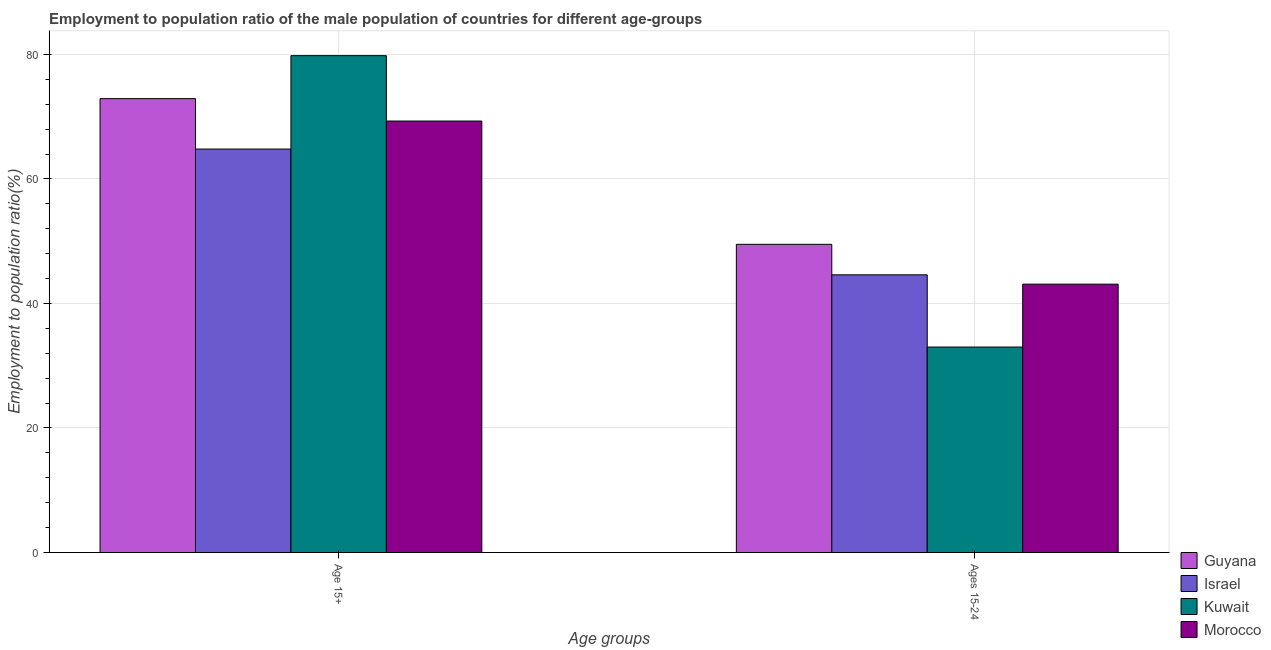How many different coloured bars are there?
Your answer should be very brief. 4. How many groups of bars are there?
Provide a short and direct response. 2. Are the number of bars per tick equal to the number of legend labels?
Give a very brief answer. Yes. How many bars are there on the 2nd tick from the left?
Provide a short and direct response. 4. How many bars are there on the 2nd tick from the right?
Keep it short and to the point. 4. What is the label of the 2nd group of bars from the left?
Provide a succinct answer. Ages 15-24. What is the employment to population ratio(age 15+) in Morocco?
Your response must be concise. 69.3. Across all countries, what is the maximum employment to population ratio(age 15+)?
Offer a very short reply. 79.8. Across all countries, what is the minimum employment to population ratio(age 15+)?
Provide a short and direct response. 64.8. In which country was the employment to population ratio(age 15+) maximum?
Provide a succinct answer. Kuwait. In which country was the employment to population ratio(age 15-24) minimum?
Ensure brevity in your answer.  Kuwait. What is the total employment to population ratio(age 15+) in the graph?
Your answer should be very brief. 286.8. What is the difference between the employment to population ratio(age 15-24) in Israel and that in Kuwait?
Keep it short and to the point. 11.6. What is the difference between the employment to population ratio(age 15+) in Morocco and the employment to population ratio(age 15-24) in Guyana?
Offer a very short reply. 19.8. What is the average employment to population ratio(age 15-24) per country?
Your answer should be compact. 42.55. What is the difference between the employment to population ratio(age 15+) and employment to population ratio(age 15-24) in Israel?
Provide a succinct answer. 20.2. What is the ratio of the employment to population ratio(age 15+) in Israel to that in Kuwait?
Your response must be concise. 0.81. In how many countries, is the employment to population ratio(age 15-24) greater than the average employment to population ratio(age 15-24) taken over all countries?
Your response must be concise. 3. What does the 4th bar from the left in Ages 15-24 represents?
Your answer should be very brief. Morocco. What does the 4th bar from the right in Age 15+ represents?
Make the answer very short. Guyana. Does the graph contain any zero values?
Provide a short and direct response. No. How are the legend labels stacked?
Provide a succinct answer. Vertical. What is the title of the graph?
Offer a terse response. Employment to population ratio of the male population of countries for different age-groups. Does "Central Europe" appear as one of the legend labels in the graph?
Give a very brief answer. No. What is the label or title of the X-axis?
Offer a very short reply. Age groups. What is the label or title of the Y-axis?
Make the answer very short. Employment to population ratio(%). What is the Employment to population ratio(%) of Guyana in Age 15+?
Offer a very short reply. 72.9. What is the Employment to population ratio(%) in Israel in Age 15+?
Ensure brevity in your answer.  64.8. What is the Employment to population ratio(%) of Kuwait in Age 15+?
Offer a very short reply. 79.8. What is the Employment to population ratio(%) in Morocco in Age 15+?
Your answer should be very brief. 69.3. What is the Employment to population ratio(%) in Guyana in Ages 15-24?
Provide a short and direct response. 49.5. What is the Employment to population ratio(%) in Israel in Ages 15-24?
Provide a short and direct response. 44.6. What is the Employment to population ratio(%) of Morocco in Ages 15-24?
Your response must be concise. 43.1. Across all Age groups, what is the maximum Employment to population ratio(%) of Guyana?
Ensure brevity in your answer.  72.9. Across all Age groups, what is the maximum Employment to population ratio(%) of Israel?
Offer a very short reply. 64.8. Across all Age groups, what is the maximum Employment to population ratio(%) of Kuwait?
Offer a very short reply. 79.8. Across all Age groups, what is the maximum Employment to population ratio(%) in Morocco?
Give a very brief answer. 69.3. Across all Age groups, what is the minimum Employment to population ratio(%) in Guyana?
Keep it short and to the point. 49.5. Across all Age groups, what is the minimum Employment to population ratio(%) of Israel?
Offer a terse response. 44.6. Across all Age groups, what is the minimum Employment to population ratio(%) in Kuwait?
Provide a succinct answer. 33. Across all Age groups, what is the minimum Employment to population ratio(%) in Morocco?
Your answer should be compact. 43.1. What is the total Employment to population ratio(%) in Guyana in the graph?
Ensure brevity in your answer.  122.4. What is the total Employment to population ratio(%) of Israel in the graph?
Your answer should be very brief. 109.4. What is the total Employment to population ratio(%) in Kuwait in the graph?
Your answer should be very brief. 112.8. What is the total Employment to population ratio(%) in Morocco in the graph?
Offer a terse response. 112.4. What is the difference between the Employment to population ratio(%) of Guyana in Age 15+ and that in Ages 15-24?
Offer a very short reply. 23.4. What is the difference between the Employment to population ratio(%) of Israel in Age 15+ and that in Ages 15-24?
Provide a succinct answer. 20.2. What is the difference between the Employment to population ratio(%) in Kuwait in Age 15+ and that in Ages 15-24?
Offer a very short reply. 46.8. What is the difference between the Employment to population ratio(%) in Morocco in Age 15+ and that in Ages 15-24?
Give a very brief answer. 26.2. What is the difference between the Employment to population ratio(%) in Guyana in Age 15+ and the Employment to population ratio(%) in Israel in Ages 15-24?
Keep it short and to the point. 28.3. What is the difference between the Employment to population ratio(%) in Guyana in Age 15+ and the Employment to population ratio(%) in Kuwait in Ages 15-24?
Your answer should be very brief. 39.9. What is the difference between the Employment to population ratio(%) of Guyana in Age 15+ and the Employment to population ratio(%) of Morocco in Ages 15-24?
Offer a terse response. 29.8. What is the difference between the Employment to population ratio(%) of Israel in Age 15+ and the Employment to population ratio(%) of Kuwait in Ages 15-24?
Keep it short and to the point. 31.8. What is the difference between the Employment to population ratio(%) in Israel in Age 15+ and the Employment to population ratio(%) in Morocco in Ages 15-24?
Offer a very short reply. 21.7. What is the difference between the Employment to population ratio(%) of Kuwait in Age 15+ and the Employment to population ratio(%) of Morocco in Ages 15-24?
Give a very brief answer. 36.7. What is the average Employment to population ratio(%) in Guyana per Age groups?
Make the answer very short. 61.2. What is the average Employment to population ratio(%) in Israel per Age groups?
Offer a very short reply. 54.7. What is the average Employment to population ratio(%) of Kuwait per Age groups?
Make the answer very short. 56.4. What is the average Employment to population ratio(%) of Morocco per Age groups?
Your response must be concise. 56.2. What is the difference between the Employment to population ratio(%) in Guyana and Employment to population ratio(%) in Israel in Age 15+?
Ensure brevity in your answer.  8.1. What is the difference between the Employment to population ratio(%) of Kuwait and Employment to population ratio(%) of Morocco in Age 15+?
Make the answer very short. 10.5. What is the difference between the Employment to population ratio(%) in Guyana and Employment to population ratio(%) in Israel in Ages 15-24?
Keep it short and to the point. 4.9. What is the difference between the Employment to population ratio(%) in Guyana and Employment to population ratio(%) in Kuwait in Ages 15-24?
Ensure brevity in your answer.  16.5. What is the ratio of the Employment to population ratio(%) in Guyana in Age 15+ to that in Ages 15-24?
Offer a very short reply. 1.47. What is the ratio of the Employment to population ratio(%) of Israel in Age 15+ to that in Ages 15-24?
Offer a very short reply. 1.45. What is the ratio of the Employment to population ratio(%) in Kuwait in Age 15+ to that in Ages 15-24?
Your answer should be very brief. 2.42. What is the ratio of the Employment to population ratio(%) of Morocco in Age 15+ to that in Ages 15-24?
Give a very brief answer. 1.61. What is the difference between the highest and the second highest Employment to population ratio(%) of Guyana?
Provide a succinct answer. 23.4. What is the difference between the highest and the second highest Employment to population ratio(%) of Israel?
Keep it short and to the point. 20.2. What is the difference between the highest and the second highest Employment to population ratio(%) of Kuwait?
Make the answer very short. 46.8. What is the difference between the highest and the second highest Employment to population ratio(%) in Morocco?
Provide a succinct answer. 26.2. What is the difference between the highest and the lowest Employment to population ratio(%) in Guyana?
Ensure brevity in your answer.  23.4. What is the difference between the highest and the lowest Employment to population ratio(%) of Israel?
Provide a short and direct response. 20.2. What is the difference between the highest and the lowest Employment to population ratio(%) of Kuwait?
Your answer should be compact. 46.8. What is the difference between the highest and the lowest Employment to population ratio(%) of Morocco?
Give a very brief answer. 26.2. 